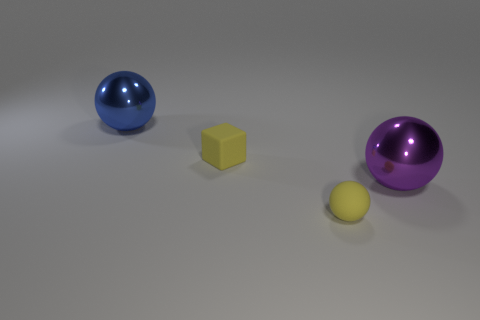Subtract all big metal spheres. How many spheres are left? 1 Add 2 big blue spheres. How many objects exist? 6 Subtract all balls. How many objects are left? 1 Add 3 yellow matte things. How many yellow matte things are left? 5 Add 3 tiny balls. How many tiny balls exist? 4 Subtract 0 red cubes. How many objects are left? 4 Subtract 1 spheres. How many spheres are left? 2 Subtract all gray cubes. Subtract all red spheres. How many cubes are left? 1 Subtract all small gray metallic things. Subtract all tiny matte blocks. How many objects are left? 3 